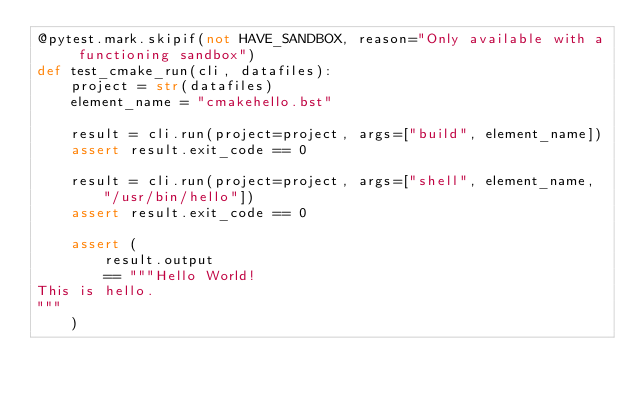Convert code to text. <code><loc_0><loc_0><loc_500><loc_500><_Python_>@pytest.mark.skipif(not HAVE_SANDBOX, reason="Only available with a functioning sandbox")
def test_cmake_run(cli, datafiles):
    project = str(datafiles)
    element_name = "cmakehello.bst"

    result = cli.run(project=project, args=["build", element_name])
    assert result.exit_code == 0

    result = cli.run(project=project, args=["shell", element_name, "/usr/bin/hello"])
    assert result.exit_code == 0

    assert (
        result.output
        == """Hello World!
This is hello.
"""
    )
</code> 